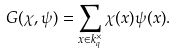<formula> <loc_0><loc_0><loc_500><loc_500>G ( \chi , \psi ) = \sum _ { x \in k _ { q } ^ { \times } } \chi ( x ) \psi ( x ) .</formula> 